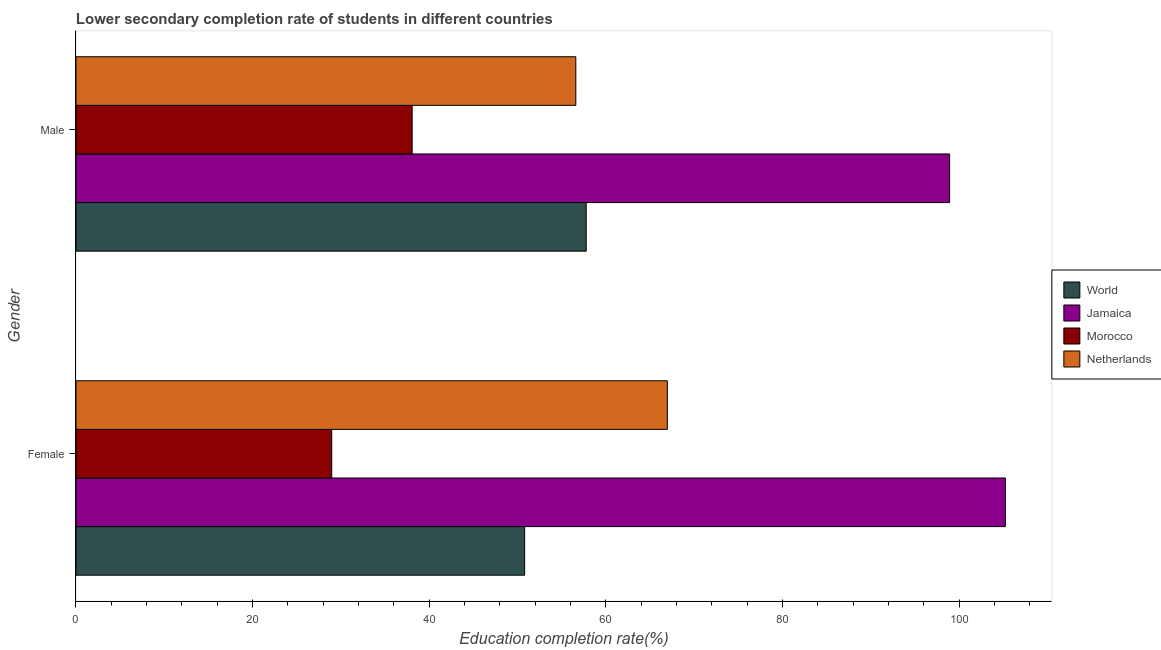How many groups of bars are there?
Keep it short and to the point. 2. Are the number of bars on each tick of the Y-axis equal?
Your answer should be compact. Yes. How many bars are there on the 1st tick from the bottom?
Offer a very short reply. 4. What is the label of the 2nd group of bars from the top?
Offer a terse response. Female. What is the education completion rate of male students in Netherlands?
Offer a terse response. 56.6. Across all countries, what is the maximum education completion rate of male students?
Give a very brief answer. 98.94. Across all countries, what is the minimum education completion rate of male students?
Provide a short and direct response. 38.07. In which country was the education completion rate of male students maximum?
Offer a very short reply. Jamaica. In which country was the education completion rate of female students minimum?
Your answer should be very brief. Morocco. What is the total education completion rate of male students in the graph?
Ensure brevity in your answer.  251.39. What is the difference between the education completion rate of male students in Netherlands and that in World?
Provide a short and direct response. -1.18. What is the difference between the education completion rate of female students in Jamaica and the education completion rate of male students in World?
Give a very brief answer. 47.47. What is the average education completion rate of female students per country?
Provide a short and direct response. 63. What is the difference between the education completion rate of female students and education completion rate of male students in Jamaica?
Your answer should be compact. 6.31. What is the ratio of the education completion rate of female students in World to that in Morocco?
Ensure brevity in your answer.  1.75. In how many countries, is the education completion rate of male students greater than the average education completion rate of male students taken over all countries?
Your response must be concise. 1. What does the 2nd bar from the top in Male represents?
Your response must be concise. Morocco. What does the 2nd bar from the bottom in Female represents?
Make the answer very short. Jamaica. Are all the bars in the graph horizontal?
Offer a very short reply. Yes. Are the values on the major ticks of X-axis written in scientific E-notation?
Provide a short and direct response. No. Does the graph contain grids?
Your response must be concise. No. What is the title of the graph?
Your answer should be compact. Lower secondary completion rate of students in different countries. Does "Iraq" appear as one of the legend labels in the graph?
Your answer should be compact. No. What is the label or title of the X-axis?
Give a very brief answer. Education completion rate(%). What is the label or title of the Y-axis?
Your answer should be compact. Gender. What is the Education completion rate(%) in World in Female?
Provide a succinct answer. 50.81. What is the Education completion rate(%) in Jamaica in Female?
Your answer should be compact. 105.25. What is the Education completion rate(%) of Morocco in Female?
Your response must be concise. 28.96. What is the Education completion rate(%) of Netherlands in Female?
Make the answer very short. 66.97. What is the Education completion rate(%) in World in Male?
Offer a very short reply. 57.78. What is the Education completion rate(%) of Jamaica in Male?
Keep it short and to the point. 98.94. What is the Education completion rate(%) of Morocco in Male?
Offer a very short reply. 38.07. What is the Education completion rate(%) in Netherlands in Male?
Offer a terse response. 56.6. Across all Gender, what is the maximum Education completion rate(%) of World?
Provide a short and direct response. 57.78. Across all Gender, what is the maximum Education completion rate(%) of Jamaica?
Keep it short and to the point. 105.25. Across all Gender, what is the maximum Education completion rate(%) in Morocco?
Offer a very short reply. 38.07. Across all Gender, what is the maximum Education completion rate(%) of Netherlands?
Your response must be concise. 66.97. Across all Gender, what is the minimum Education completion rate(%) of World?
Keep it short and to the point. 50.81. Across all Gender, what is the minimum Education completion rate(%) in Jamaica?
Offer a very short reply. 98.94. Across all Gender, what is the minimum Education completion rate(%) in Morocco?
Offer a very short reply. 28.96. Across all Gender, what is the minimum Education completion rate(%) in Netherlands?
Provide a short and direct response. 56.6. What is the total Education completion rate(%) of World in the graph?
Offer a very short reply. 108.59. What is the total Education completion rate(%) of Jamaica in the graph?
Keep it short and to the point. 204.19. What is the total Education completion rate(%) in Morocco in the graph?
Offer a very short reply. 67.03. What is the total Education completion rate(%) of Netherlands in the graph?
Provide a succinct answer. 123.58. What is the difference between the Education completion rate(%) of World in Female and that in Male?
Provide a succinct answer. -6.97. What is the difference between the Education completion rate(%) of Jamaica in Female and that in Male?
Your answer should be very brief. 6.31. What is the difference between the Education completion rate(%) in Morocco in Female and that in Male?
Provide a succinct answer. -9.11. What is the difference between the Education completion rate(%) of Netherlands in Female and that in Male?
Offer a very short reply. 10.37. What is the difference between the Education completion rate(%) of World in Female and the Education completion rate(%) of Jamaica in Male?
Keep it short and to the point. -48.13. What is the difference between the Education completion rate(%) of World in Female and the Education completion rate(%) of Morocco in Male?
Ensure brevity in your answer.  12.74. What is the difference between the Education completion rate(%) of World in Female and the Education completion rate(%) of Netherlands in Male?
Offer a very short reply. -5.8. What is the difference between the Education completion rate(%) of Jamaica in Female and the Education completion rate(%) of Morocco in Male?
Offer a very short reply. 67.18. What is the difference between the Education completion rate(%) of Jamaica in Female and the Education completion rate(%) of Netherlands in Male?
Your answer should be very brief. 48.65. What is the difference between the Education completion rate(%) in Morocco in Female and the Education completion rate(%) in Netherlands in Male?
Make the answer very short. -27.64. What is the average Education completion rate(%) in World per Gender?
Offer a terse response. 54.3. What is the average Education completion rate(%) in Jamaica per Gender?
Keep it short and to the point. 102.09. What is the average Education completion rate(%) of Morocco per Gender?
Keep it short and to the point. 33.52. What is the average Education completion rate(%) of Netherlands per Gender?
Ensure brevity in your answer.  61.79. What is the difference between the Education completion rate(%) of World and Education completion rate(%) of Jamaica in Female?
Give a very brief answer. -54.44. What is the difference between the Education completion rate(%) of World and Education completion rate(%) of Morocco in Female?
Provide a short and direct response. 21.85. What is the difference between the Education completion rate(%) of World and Education completion rate(%) of Netherlands in Female?
Make the answer very short. -16.16. What is the difference between the Education completion rate(%) in Jamaica and Education completion rate(%) in Morocco in Female?
Give a very brief answer. 76.29. What is the difference between the Education completion rate(%) in Jamaica and Education completion rate(%) in Netherlands in Female?
Ensure brevity in your answer.  38.28. What is the difference between the Education completion rate(%) in Morocco and Education completion rate(%) in Netherlands in Female?
Keep it short and to the point. -38.01. What is the difference between the Education completion rate(%) of World and Education completion rate(%) of Jamaica in Male?
Provide a short and direct response. -41.15. What is the difference between the Education completion rate(%) of World and Education completion rate(%) of Morocco in Male?
Provide a short and direct response. 19.71. What is the difference between the Education completion rate(%) in World and Education completion rate(%) in Netherlands in Male?
Offer a very short reply. 1.18. What is the difference between the Education completion rate(%) of Jamaica and Education completion rate(%) of Morocco in Male?
Your answer should be compact. 60.86. What is the difference between the Education completion rate(%) in Jamaica and Education completion rate(%) in Netherlands in Male?
Make the answer very short. 42.33. What is the difference between the Education completion rate(%) of Morocco and Education completion rate(%) of Netherlands in Male?
Ensure brevity in your answer.  -18.53. What is the ratio of the Education completion rate(%) of World in Female to that in Male?
Give a very brief answer. 0.88. What is the ratio of the Education completion rate(%) of Jamaica in Female to that in Male?
Make the answer very short. 1.06. What is the ratio of the Education completion rate(%) in Morocco in Female to that in Male?
Your response must be concise. 0.76. What is the ratio of the Education completion rate(%) in Netherlands in Female to that in Male?
Offer a very short reply. 1.18. What is the difference between the highest and the second highest Education completion rate(%) of World?
Provide a short and direct response. 6.97. What is the difference between the highest and the second highest Education completion rate(%) in Jamaica?
Offer a terse response. 6.31. What is the difference between the highest and the second highest Education completion rate(%) in Morocco?
Your answer should be compact. 9.11. What is the difference between the highest and the second highest Education completion rate(%) in Netherlands?
Keep it short and to the point. 10.37. What is the difference between the highest and the lowest Education completion rate(%) of World?
Your answer should be very brief. 6.97. What is the difference between the highest and the lowest Education completion rate(%) in Jamaica?
Ensure brevity in your answer.  6.31. What is the difference between the highest and the lowest Education completion rate(%) in Morocco?
Provide a short and direct response. 9.11. What is the difference between the highest and the lowest Education completion rate(%) of Netherlands?
Your answer should be compact. 10.37. 